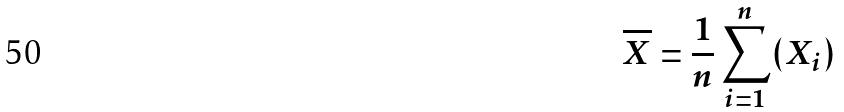Convert formula to latex. <formula><loc_0><loc_0><loc_500><loc_500>\overline { X } = \frac { 1 } { n } \sum _ { i = 1 } ^ { n } ( X _ { i } )</formula> 